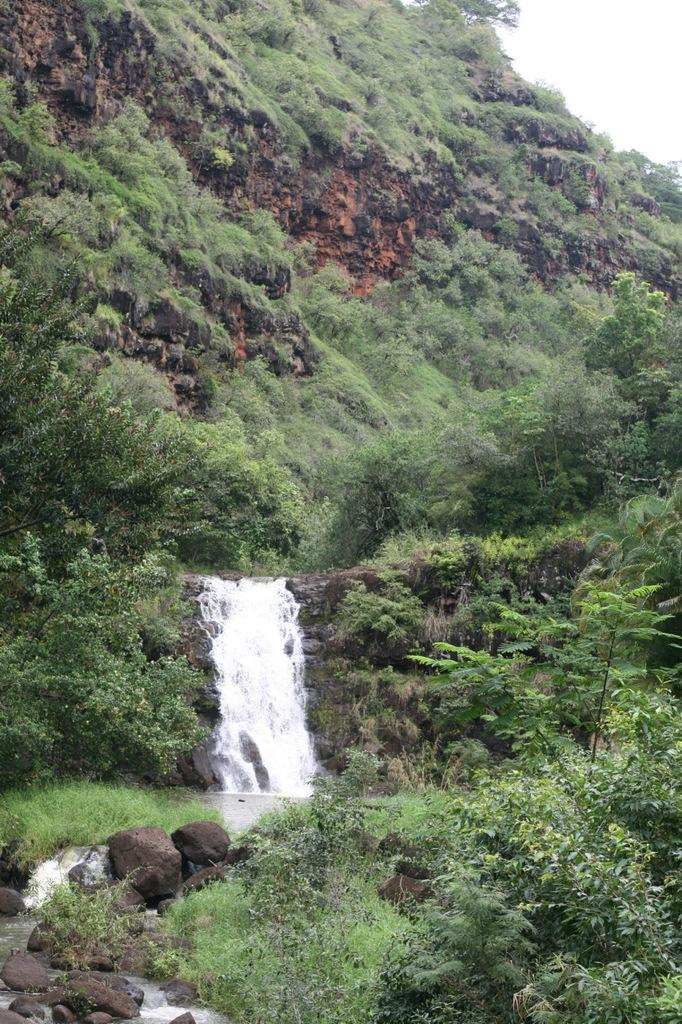What geographical feature is the main subject of the image? There is a mountain in the image. What can be found on the mountain? There are rocks, trees, and plants on the mountain. What natural feature is located in the center of the image? There is a waterfall in the center of the image. What part of the sky is visible in the image? The sky is visible in the top right corner of the image. What type of furniture can be seen on the edge of the mountain in the image? There is no furniture present in the image, and the mountain does not have an edge. 